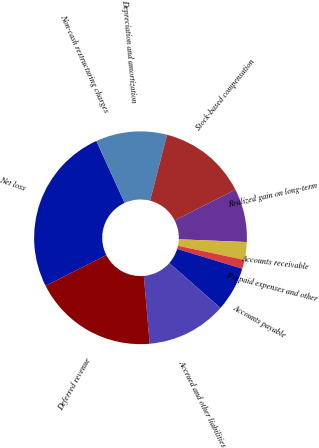Convert chart to OTSL. <chart><loc_0><loc_0><loc_500><loc_500><pie_chart><fcel>Net loss<fcel>Non-cash restructuring charges<fcel>Depreciation and amortization<fcel>Stock-based compensation<fcel>Realized gain on long-term<fcel>Accounts receivable<fcel>Prepaid expenses and other<fcel>Accounts payable<fcel>Accrued and other liabilities<fcel>Deferred revenue<nl><fcel>25.65%<fcel>0.01%<fcel>10.81%<fcel>13.51%<fcel>8.11%<fcel>2.71%<fcel>1.36%<fcel>6.76%<fcel>12.16%<fcel>18.91%<nl></chart> 